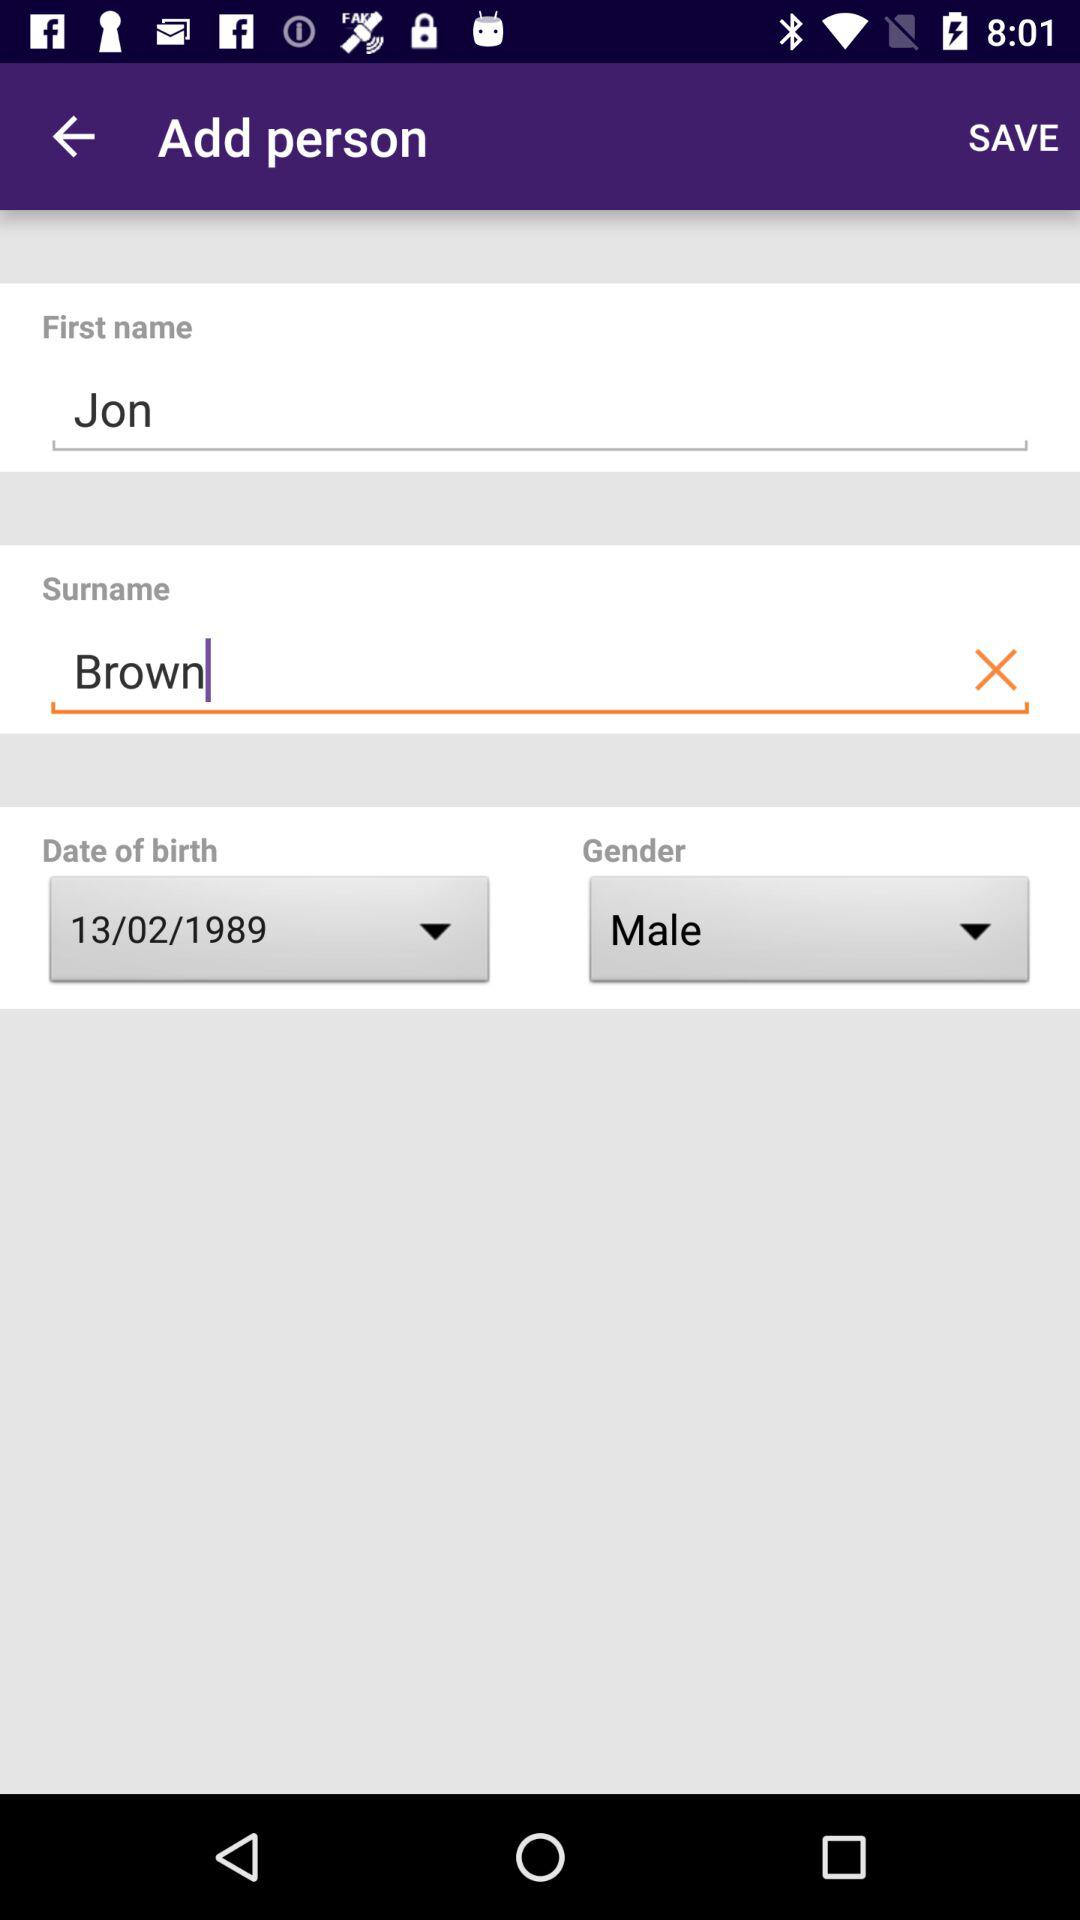How tall is Jon Brown?
When the provided information is insufficient, respond with <no answer>. <no answer> 